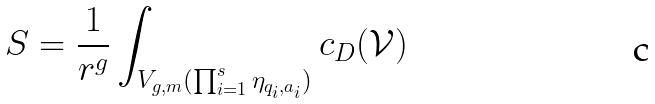<formula> <loc_0><loc_0><loc_500><loc_500>S = \frac { 1 } { r ^ { g } } \int _ { V _ { g , m } ( \prod _ { i = 1 } ^ { s } \eta _ { q _ { i } , a _ { i } } ) } c _ { D } ( \mathcal { V } )</formula> 